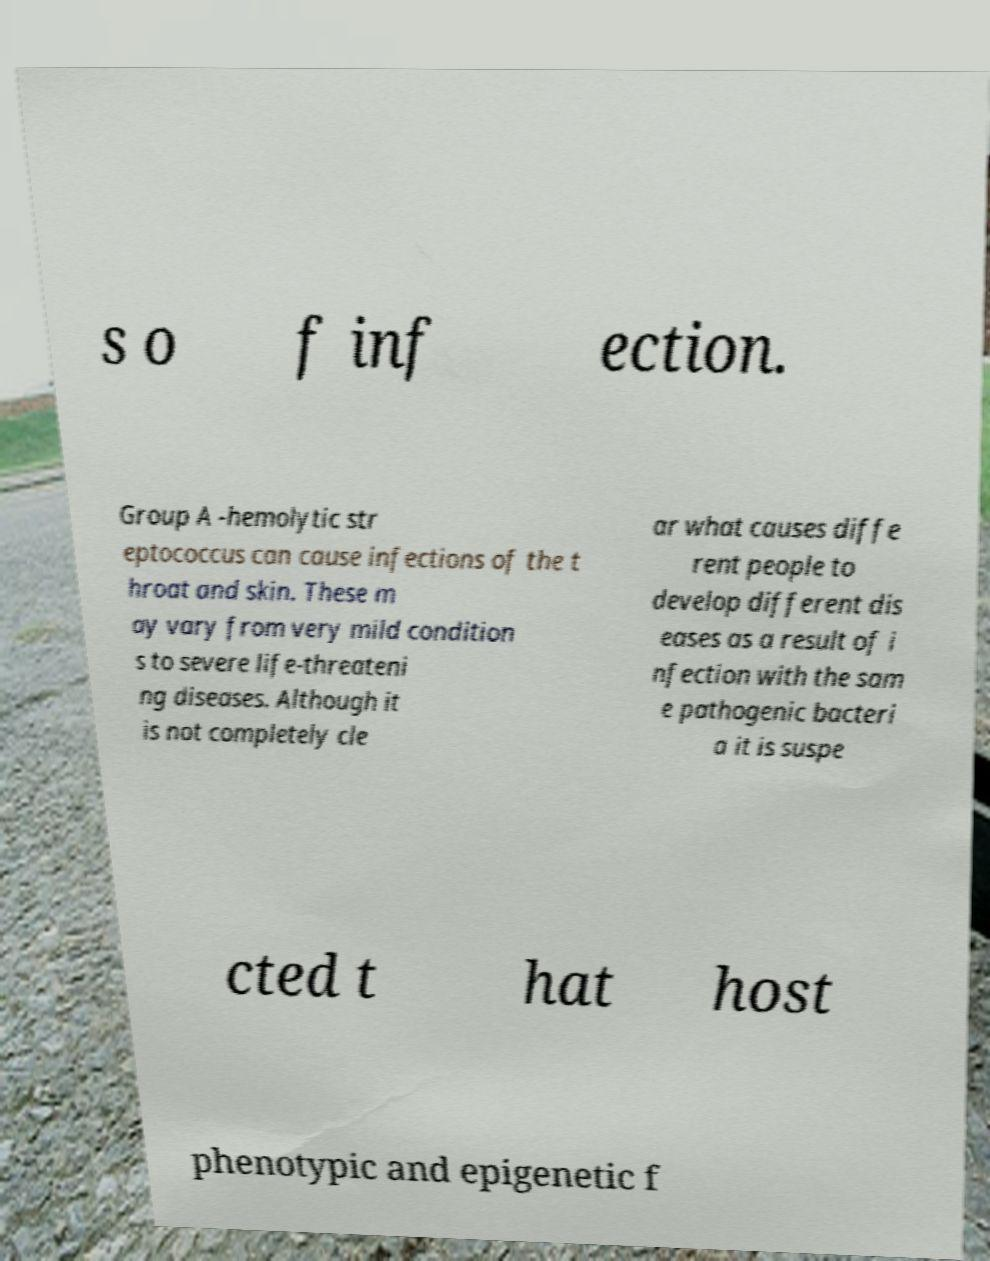For documentation purposes, I need the text within this image transcribed. Could you provide that? s o f inf ection. Group A -hemolytic str eptococcus can cause infections of the t hroat and skin. These m ay vary from very mild condition s to severe life-threateni ng diseases. Although it is not completely cle ar what causes diffe rent people to develop different dis eases as a result of i nfection with the sam e pathogenic bacteri a it is suspe cted t hat host phenotypic and epigenetic f 